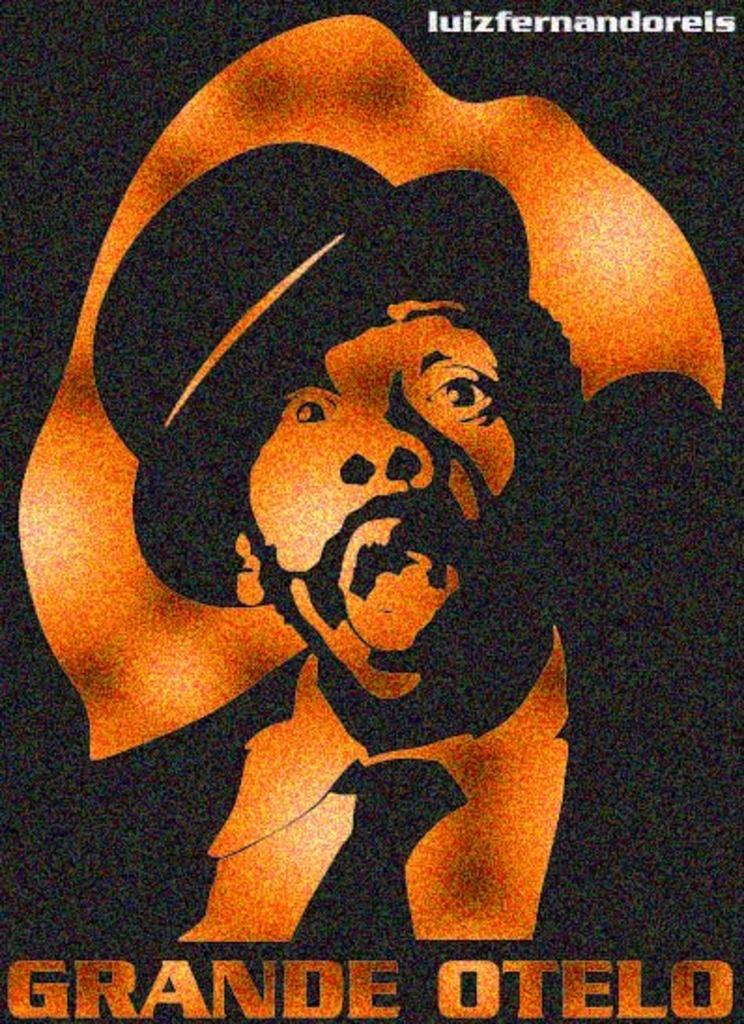Provide a one-sentence caption for the provided image. The show being featured on the poster is called Grande Otelo. 